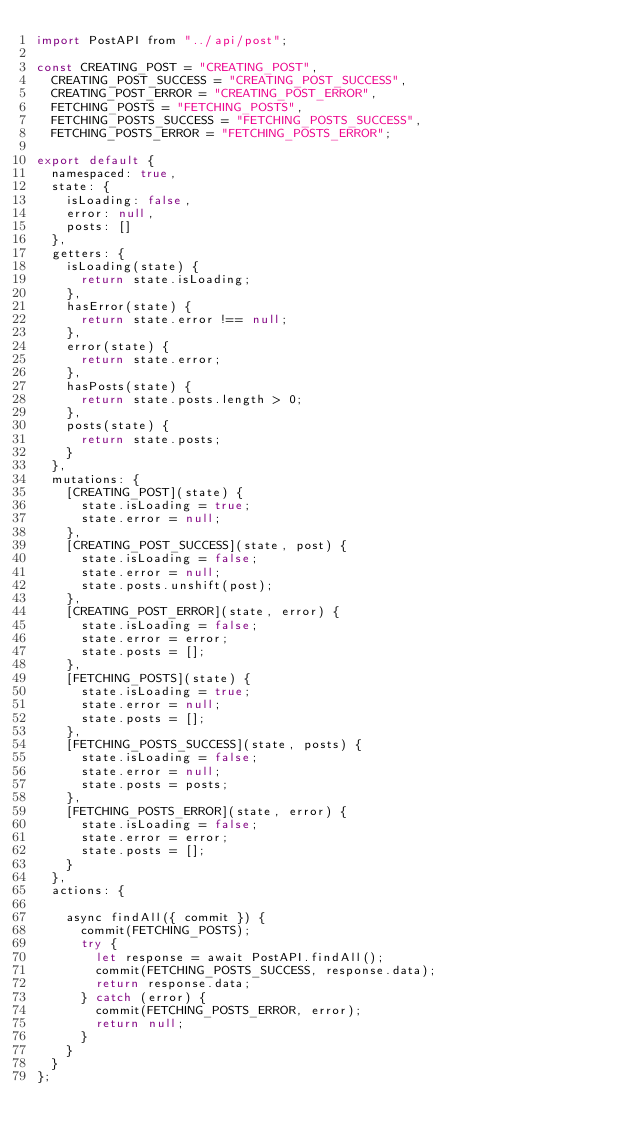<code> <loc_0><loc_0><loc_500><loc_500><_JavaScript_>import PostAPI from "../api/post";

const CREATING_POST = "CREATING_POST",
  CREATING_POST_SUCCESS = "CREATING_POST_SUCCESS",
  CREATING_POST_ERROR = "CREATING_POST_ERROR",
  FETCHING_POSTS = "FETCHING_POSTS",
  FETCHING_POSTS_SUCCESS = "FETCHING_POSTS_SUCCESS",
  FETCHING_POSTS_ERROR = "FETCHING_POSTS_ERROR";

export default {
  namespaced: true,
  state: {
    isLoading: false,
    error: null,
    posts: []
  },
  getters: {
    isLoading(state) {
      return state.isLoading;
    },
    hasError(state) {
      return state.error !== null;
    },
    error(state) {
      return state.error;
    },
    hasPosts(state) {
      return state.posts.length > 0;
    },
    posts(state) {
      return state.posts;
    }
  },
  mutations: {
    [CREATING_POST](state) {
      state.isLoading = true;
      state.error = null;
    },
    [CREATING_POST_SUCCESS](state, post) {
      state.isLoading = false;
      state.error = null;
      state.posts.unshift(post);
    },
    [CREATING_POST_ERROR](state, error) {
      state.isLoading = false;
      state.error = error;
      state.posts = [];
    },
    [FETCHING_POSTS](state) {
      state.isLoading = true;
      state.error = null;
      state.posts = [];
    },
    [FETCHING_POSTS_SUCCESS](state, posts) {
      state.isLoading = false;
      state.error = null;
      state.posts = posts;
    },
    [FETCHING_POSTS_ERROR](state, error) {
      state.isLoading = false;
      state.error = error;
      state.posts = [];
    }
  },
  actions: {

    async findAll({ commit }) {
      commit(FETCHING_POSTS);
      try {
        let response = await PostAPI.findAll();
        commit(FETCHING_POSTS_SUCCESS, response.data);
        return response.data;
      } catch (error) {
        commit(FETCHING_POSTS_ERROR, error);
        return null;
      }
    }
  }
};
</code> 